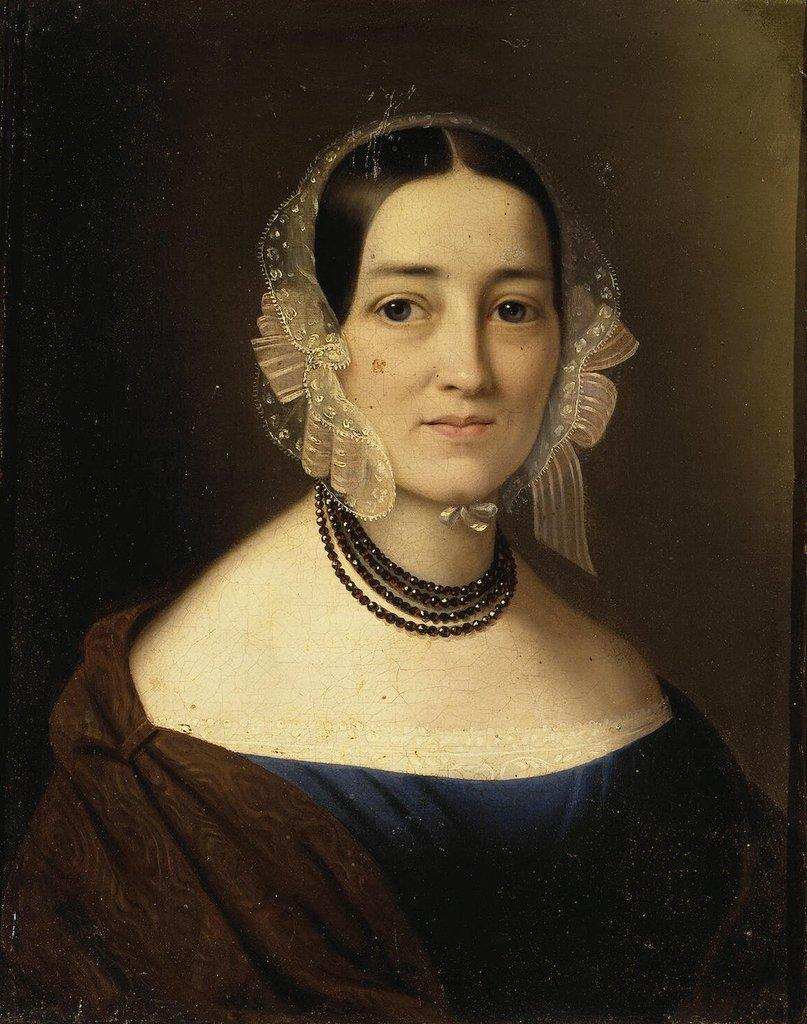What is the main subject of the image? There is a sketch of a lady in the image. Can you describe the background of the image? The background of the image is blurred. What type of ink was used to create the sketch in the image? There is no information about the type of ink used in the image, as it is a sketch and not a photograph. 